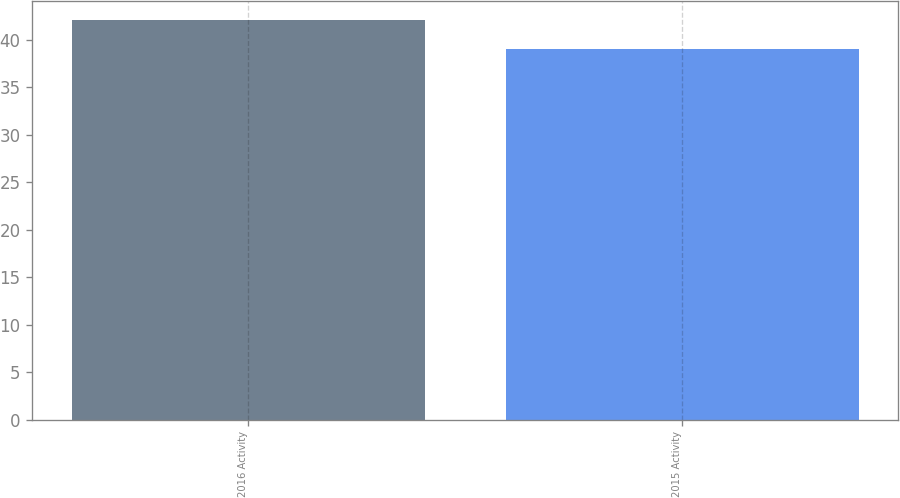<chart> <loc_0><loc_0><loc_500><loc_500><bar_chart><fcel>2016 Activity<fcel>2015 Activity<nl><fcel>42<fcel>39<nl></chart> 